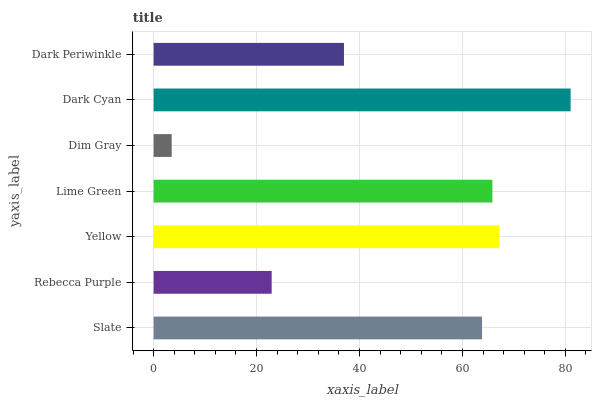Is Dim Gray the minimum?
Answer yes or no. Yes. Is Dark Cyan the maximum?
Answer yes or no. Yes. Is Rebecca Purple the minimum?
Answer yes or no. No. Is Rebecca Purple the maximum?
Answer yes or no. No. Is Slate greater than Rebecca Purple?
Answer yes or no. Yes. Is Rebecca Purple less than Slate?
Answer yes or no. Yes. Is Rebecca Purple greater than Slate?
Answer yes or no. No. Is Slate less than Rebecca Purple?
Answer yes or no. No. Is Slate the high median?
Answer yes or no. Yes. Is Slate the low median?
Answer yes or no. Yes. Is Yellow the high median?
Answer yes or no. No. Is Yellow the low median?
Answer yes or no. No. 